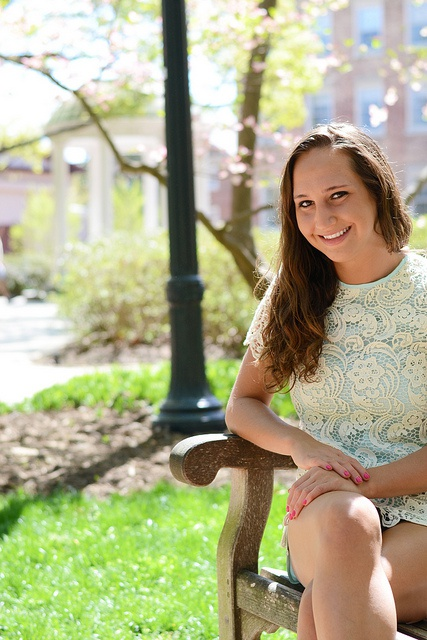Describe the objects in this image and their specific colors. I can see people in khaki, gray, darkgray, and tan tones and bench in khaki, tan, maroon, gray, and lightgreen tones in this image. 